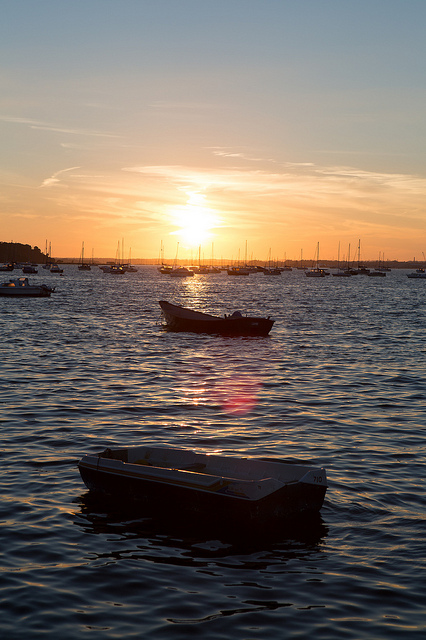<image>How tall is the wave? It is unknown how tall the wave is. It could be small or not tall. How tall is the wave? It is unknown how tall the wave is. 